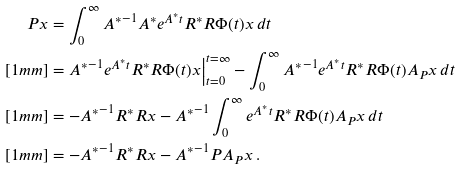Convert formula to latex. <formula><loc_0><loc_0><loc_500><loc_500>P x & = \int _ { 0 } ^ { \infty } { A ^ { * } } ^ { - 1 } A ^ { * } e ^ { A ^ { * } t } R ^ { * } R \Phi ( t ) x \, d t \\ [ 1 m m ] & = { A ^ { * } } ^ { - 1 } e ^ { A ^ { * } t } R ^ { * } R \Phi ( t ) x \Big | _ { t = 0 } ^ { t = \infty } - \int _ { 0 } ^ { \infty } { A ^ { * } } ^ { - 1 } e ^ { A ^ { * } t } R ^ { * } R \Phi ( t ) A _ { P } x \, d t \\ [ 1 m m ] & = - { A ^ { * } } ^ { - 1 } R ^ { * } R x - { A ^ { * } } ^ { - 1 } \int _ { 0 } ^ { \infty } e ^ { A ^ { * } t } R ^ { * } R \Phi ( t ) A _ { P } x \, d t \\ [ 1 m m ] & = - { A ^ { * } } ^ { - 1 } R ^ { * } R x - { A ^ { * } } ^ { - 1 } P A _ { P } x \, .</formula> 